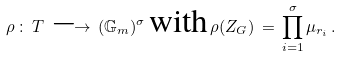<formula> <loc_0><loc_0><loc_500><loc_500>\rho \, \colon \, T \, \longrightarrow \, ( { \mathbb { G } } _ { m } ) ^ { \sigma } \, \text {with} \, \rho ( Z _ { G } ) \, = \, \prod _ { i = 1 } ^ { \sigma } \mu _ { r _ { i } } \, .</formula> 